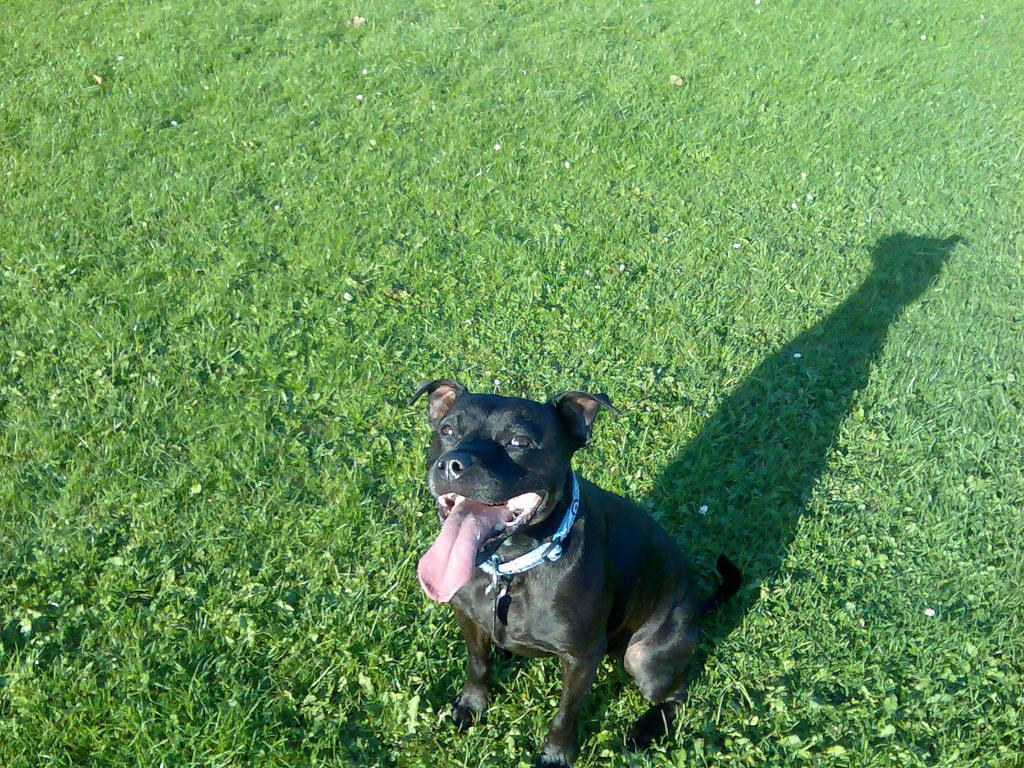What is located in the foreground of the picture? There is a dog in the foreground of the picture. What type of surface is the dog standing on? There is grass in the foreground of the picture, which is the surface the dog is standing on. Where is the dog's shadow located in the image? The dog's shadow is visible towards the right side of the image. What can be seen at the top of the image? There is grass visible at the top of the image. What type of celery is being used as a prop in the image? There is no celery present in the image. What is the yam doing in the middle of the image? There is no yam present in the image. 